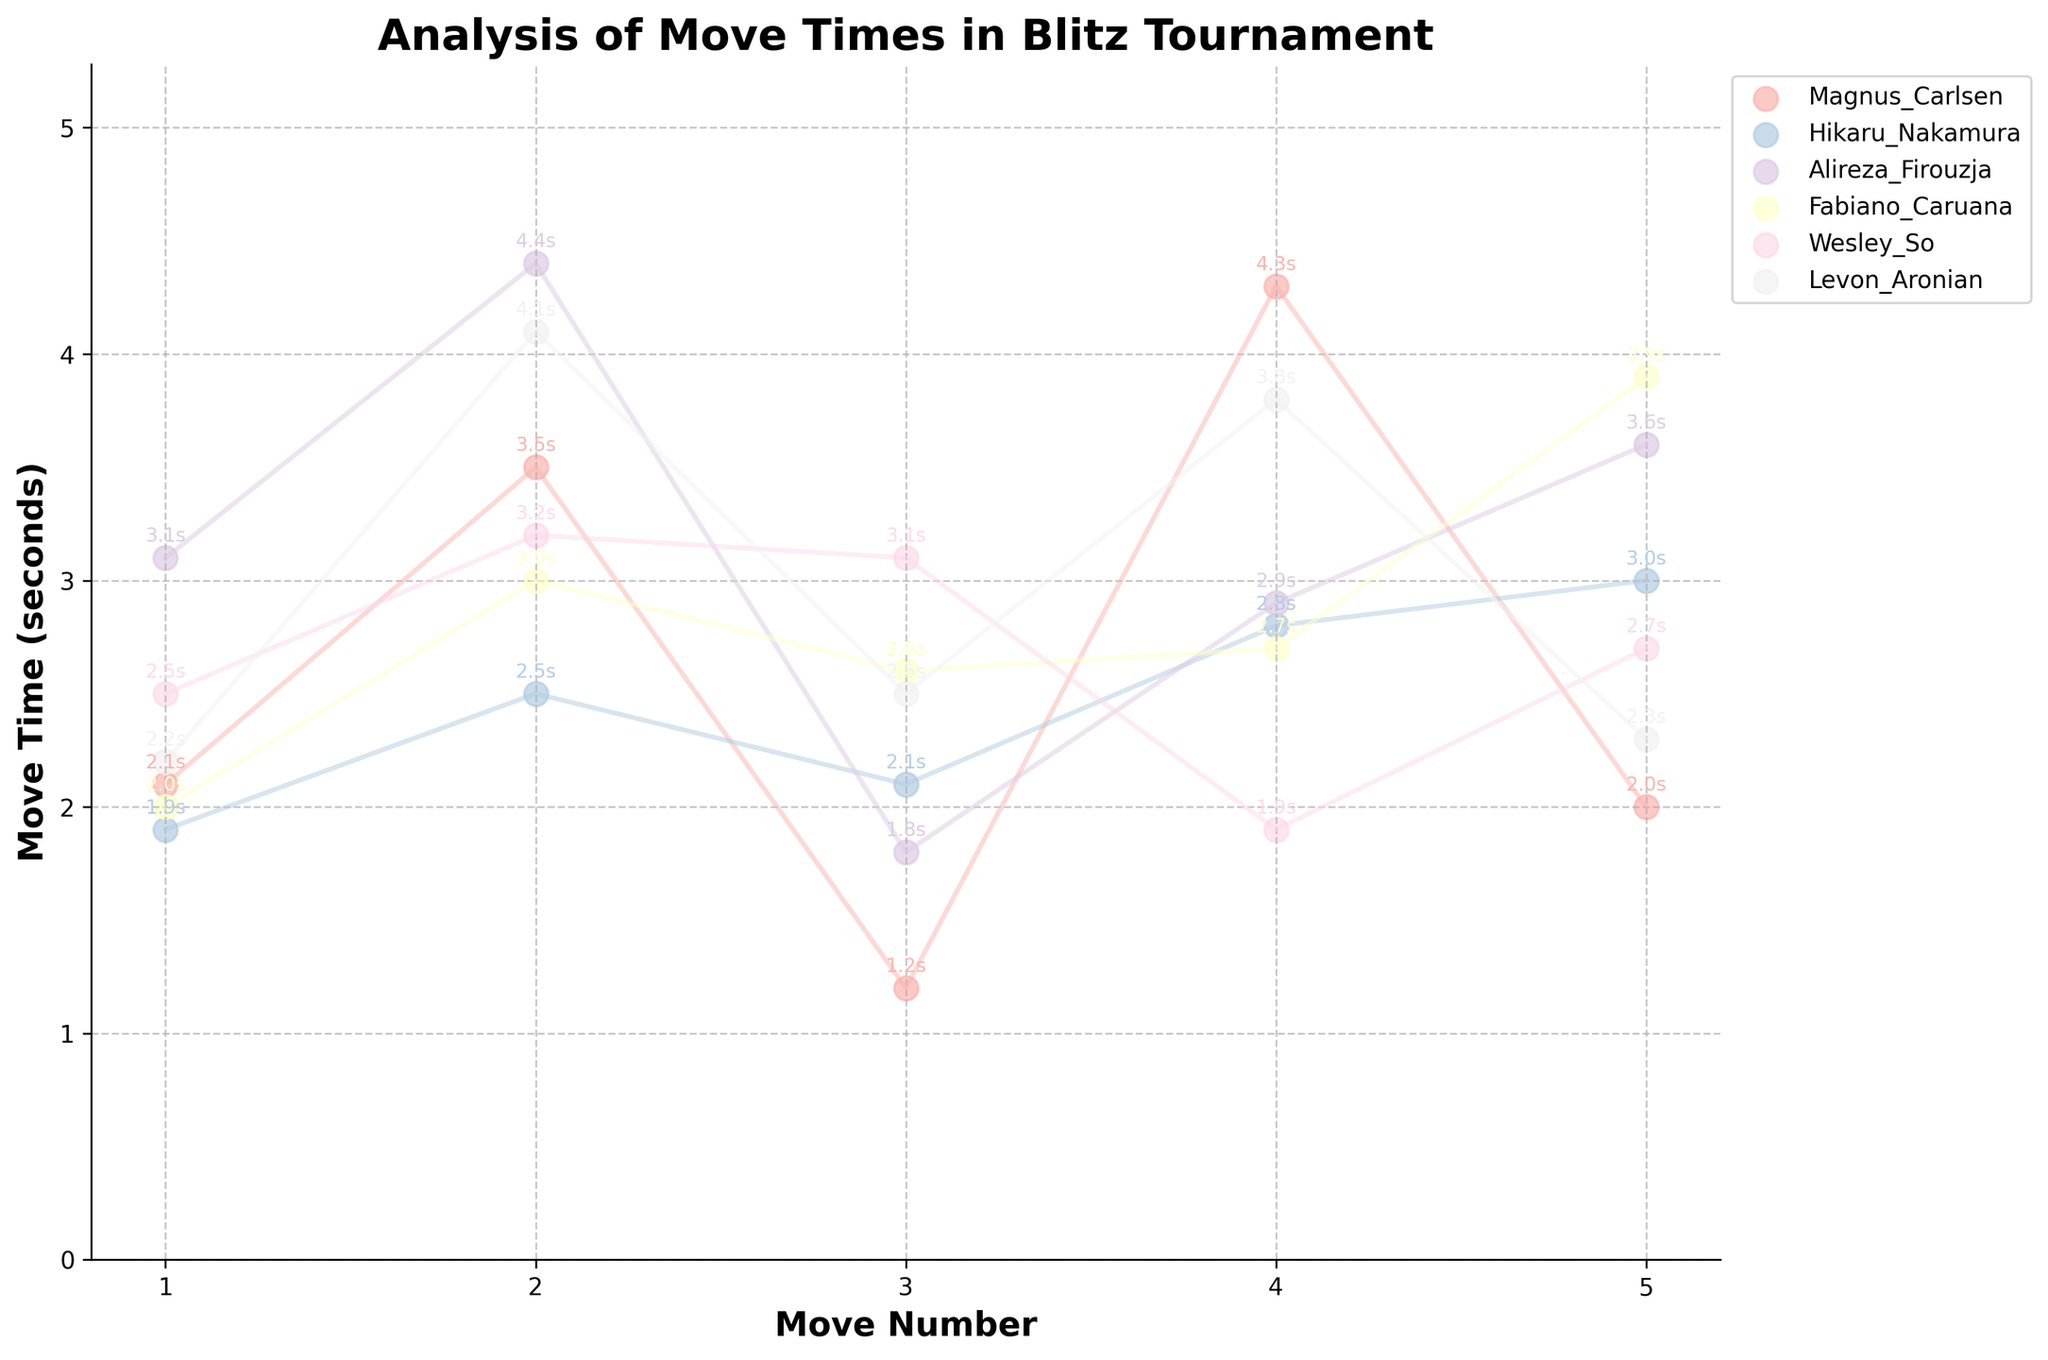What is the title of the figure? The title is located at the top of the figure and reads "Analysis of Move Times in Blitz Tournament."
Answer: Analysis of Move Times in Blitz Tournament What does the x-axis represent? The x-axis label is clearly stated at the bottom of the figure as "Move Number."
Answer: Move Number How many moves are plotted for each player? The x-axis has ticks from 1 to 5, indicating 5 moves plotted for each player.
Answer: 5 Which player has the longest move time, and what is the value? The scatter points and annotations show that Alireza Firouzja has the longest move time, which is 4.4 seconds.
Answer: Alireza Firouzja with 4.4 seconds What is the average move time for Magnus Carlsen? To find the average: (2.1 + 3.5 + 1.2 + 4.3 + 2.0) / 5. Sum is 13.1, divide by 5 gives 2.62 seconds.
Answer: 2.62 seconds Which game has the least variance in move times? By visually inspecting the tight clustering of moves, Hikaru Nakamura's move times in game 1 have the least variance.
Answer: Game with Hikaru Nakamura Among the winners, who has the highest average move time? The winners are Magnus Carlsen and Alireza Firouzja. Comparing their averages, (2.1+3.5+1.2+4.3+2.0)/5 = 2.62 and (3.1+4.4+1.8+2.9+3.6)/5 = 3.16; Alireza Firouzja has the highest average.
Answer: Alireza Firouzja How do the average move times compare between the players who drew the game? The players who drew are Wesley So and Levon Aronian. Their averages are (2.5+3.2+3.1+1.9+2.7)/5 = 2.68 and (2.2+4.1+2.5+3.8+2.3)/5 = 2.98. Wesley So's is lower.
Answer: Wesley So has a lower average What is the difference in move time between the shortest and longest moves for Fabiano Caruana? Fabiano Caruana's move times are 2.0, 3.0, 2.6, 2.7, 3.9. The shortest is 2.0 and the longest is 3.9. The difference is 3.9 - 2.0 = 1.9 seconds.
Answer: 1.9 seconds Which player has the most consistent move times, and what is the supporting evidence? Hikaru Nakamura's moves are clustered closely and have lower variance, compared to other players with larger fluctuations (by visual inspection).
Answer: Hikaru Nakamura 